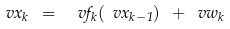Convert formula to latex. <formula><loc_0><loc_0><loc_500><loc_500>\ v x _ { k } \ = \ \ v f _ { k } ( \ v x _ { k - 1 } ) \ + \ v w _ { k }</formula> 